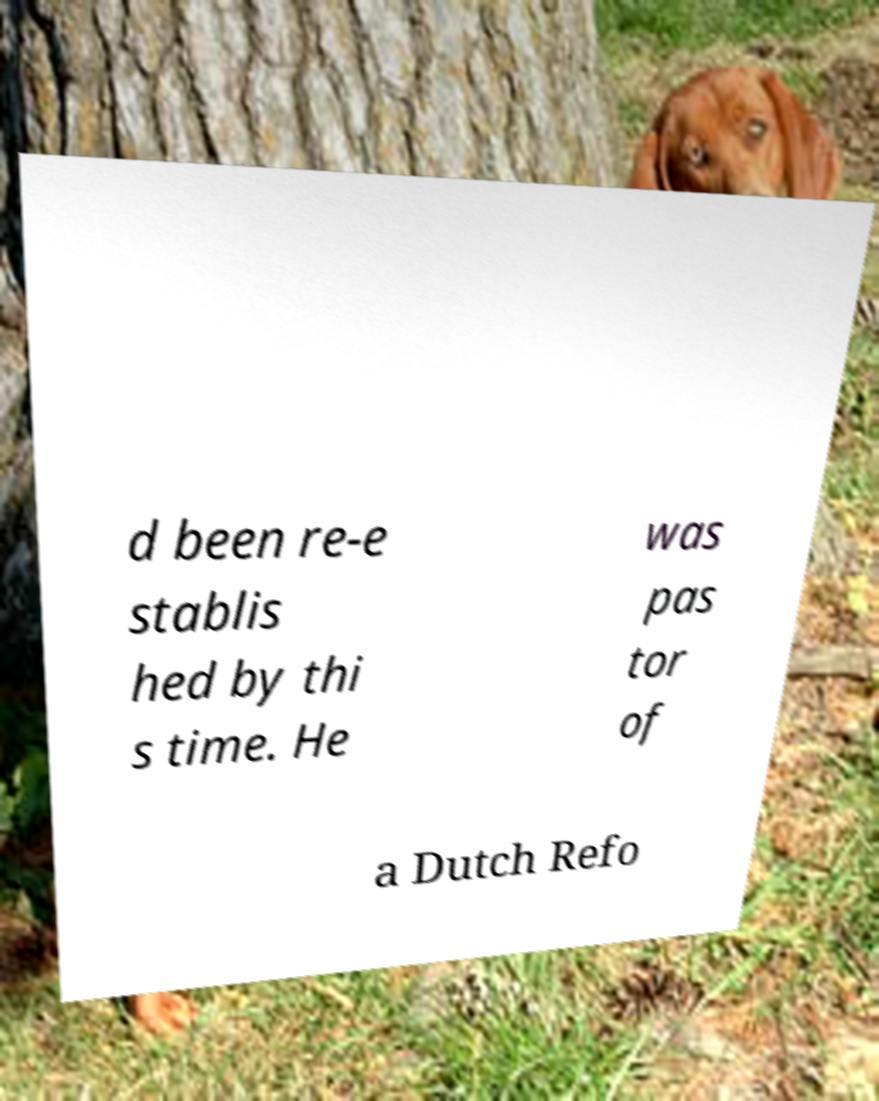Could you assist in decoding the text presented in this image and type it out clearly? d been re-e stablis hed by thi s time. He was pas tor of a Dutch Refo 